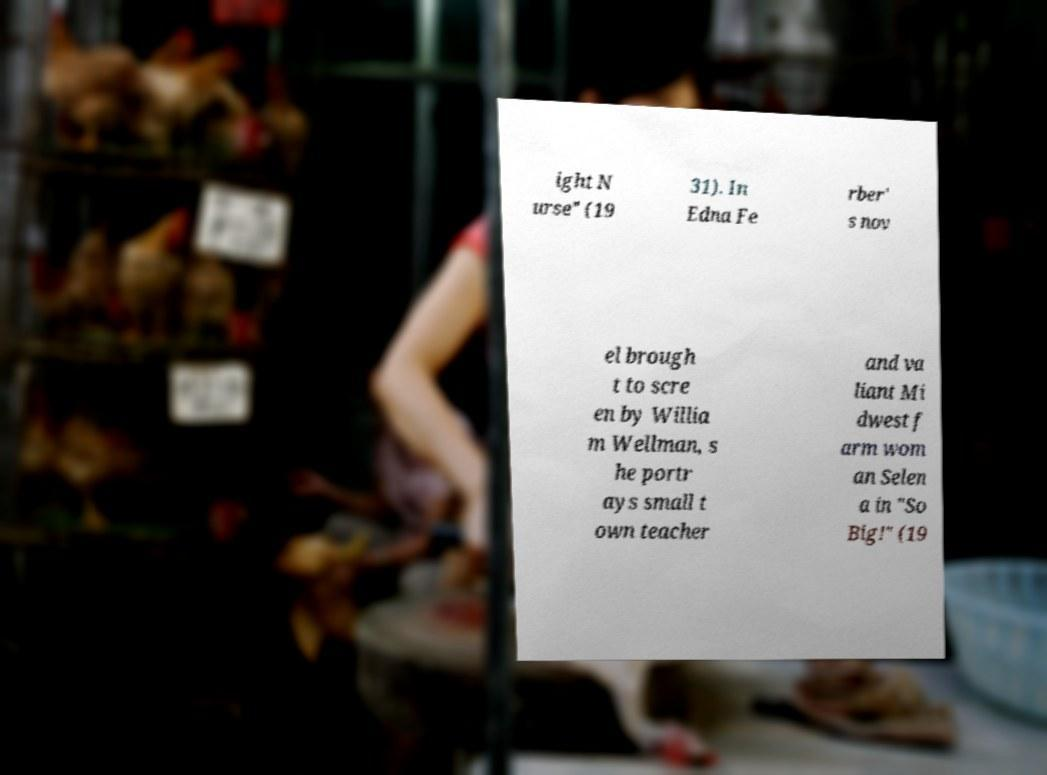Please read and relay the text visible in this image. What does it say? ight N urse" (19 31). In Edna Fe rber' s nov el brough t to scre en by Willia m Wellman, s he portr ays small t own teacher and va liant Mi dwest f arm wom an Selen a in "So Big!" (19 